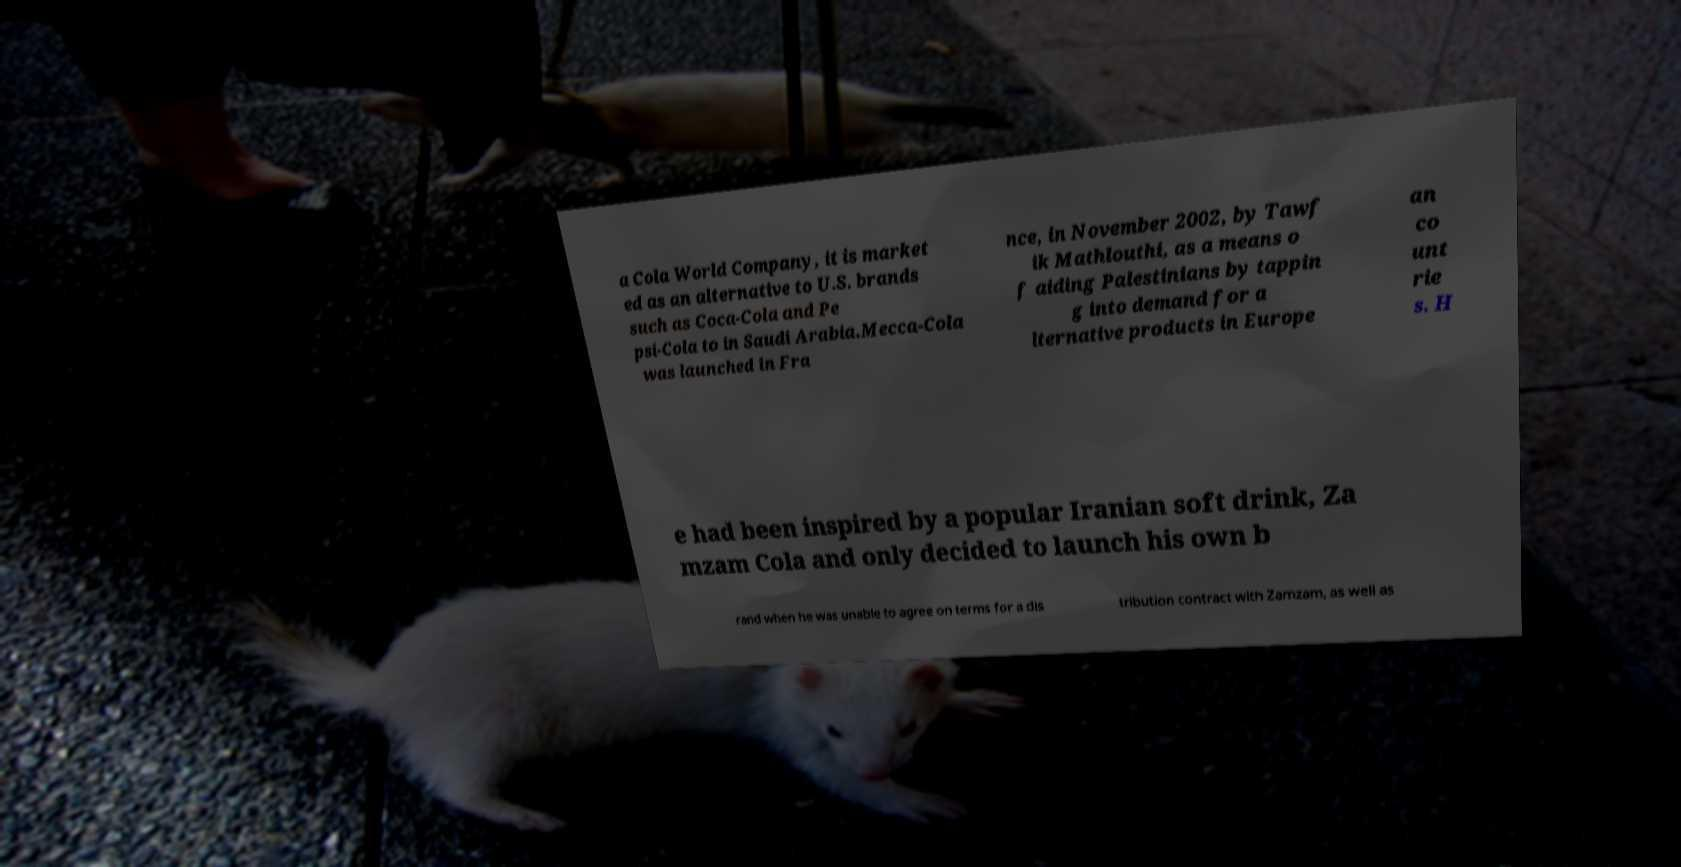Can you accurately transcribe the text from the provided image for me? a Cola World Company, it is market ed as an alternative to U.S. brands such as Coca-Cola and Pe psi-Cola to in Saudi Arabia.Mecca-Cola was launched in Fra nce, in November 2002, by Tawf ik Mathlouthi, as a means o f aiding Palestinians by tappin g into demand for a lternative products in Europe an co unt rie s. H e had been inspired by a popular Iranian soft drink, Za mzam Cola and only decided to launch his own b rand when he was unable to agree on terms for a dis tribution contract with Zamzam, as well as 